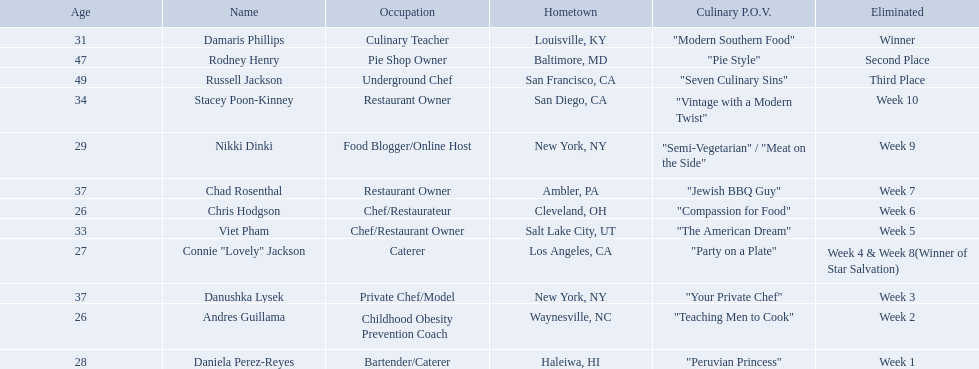Who are the listed food network star contestants? Damaris Phillips, Rodney Henry, Russell Jackson, Stacey Poon-Kinney, Nikki Dinki, Chad Rosenthal, Chris Hodgson, Viet Pham, Connie "Lovely" Jackson, Danushka Lysek, Andres Guillama, Daniela Perez-Reyes. Of those who had the longest p.o.v title? Nikki Dinki. 